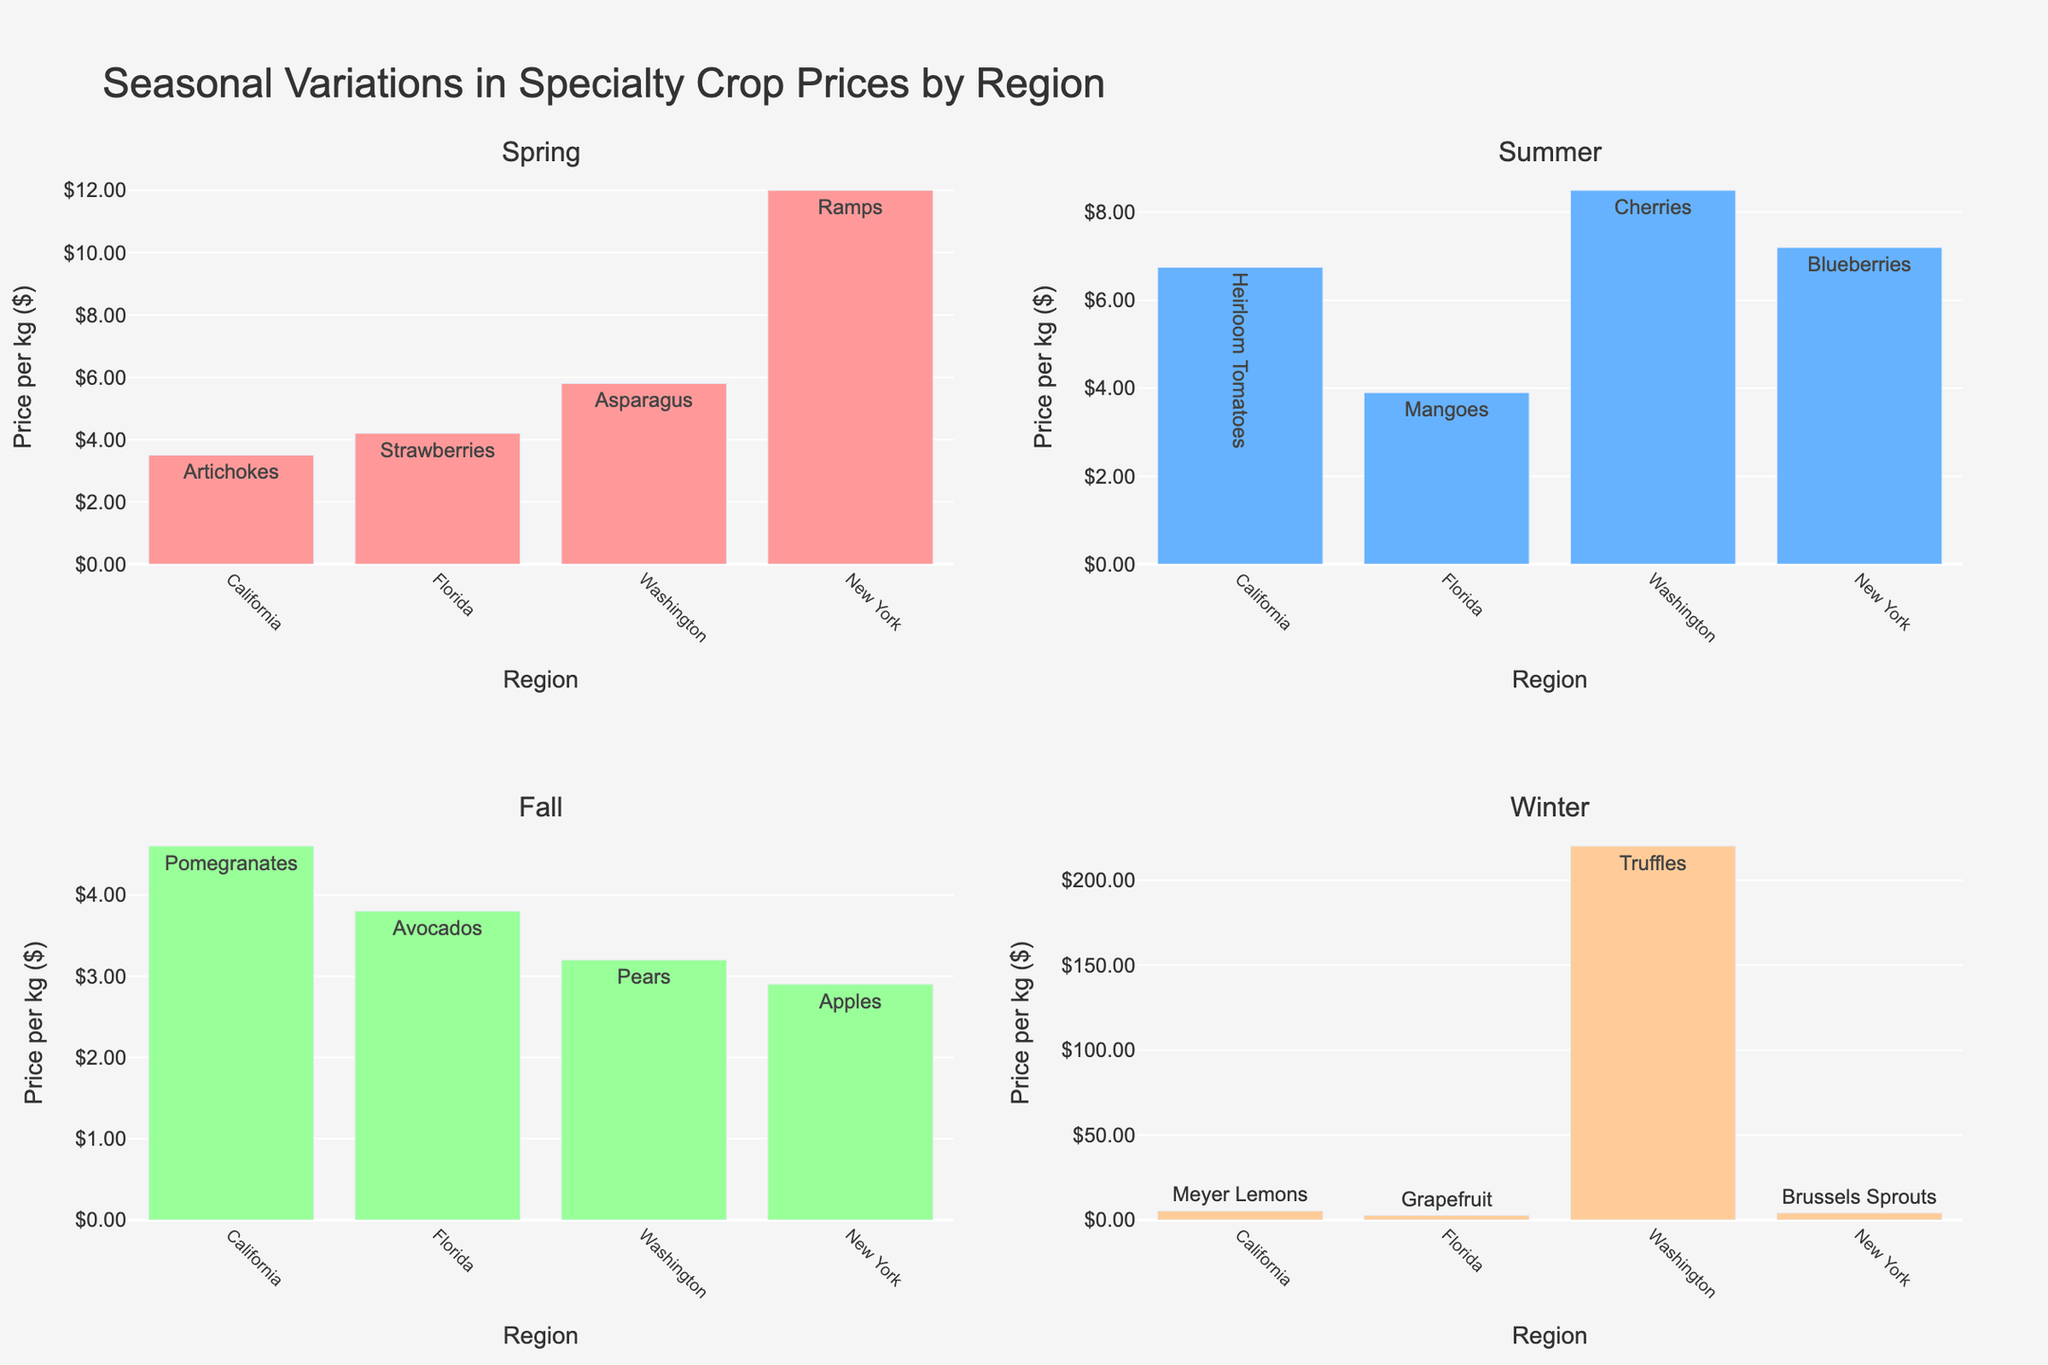How many regions are represented in the figure? There are four regions shown in each subplot: California, Florida, Washington, and New York. By counting them in any one of the subplots, we can determine the number of regions.
Answer: 4 Which season has the highest price for a single crop? The Winter subplot shows Truffles in Washington with a price of $220.00 per kg, which is the highest among all crops shown.
Answer: Winter Which region in the Spring season has the highest-priced crop, and what is it? In the Spring subplot, Ramps in New York are priced at $12.00 per kg which is the highest among the regions for this season.
Answer: New York, Ramps What is the average price of crops in the Summer season? Sum all the prices in the Summer subplot: $6.75 (California) + $3.90 (Florida) + $8.50 (Washington) + $7.20 (New York) = $26.35. Divide the total by 4 (number of regions): $26.35 / 4 = $6.5875.
Answer: $6.59 Compare the price of Apples in New York during the Fall season with the price of Pomegranates in California during the same season. Which is higher? In the Fall subplot, Apples in New York are priced at $2.90 per kg, while Pomegranates in California are priced at $4.60 per kg. Hence, Pomegranates are higher in price.
Answer: Pomegranates Which season has the lowest overall price for its crops, considering all regions? Adding up the prices for each season:
- Spring: $3.50 + $4.20 + $5.80 + $12.00 = $25.50
- Summer: $6.75 + $3.90 + $8.50 + $7.20 = $26.35
- Fall: $4.60 + $3.80 + $3.20 + $2.90 = $14.50
- Winter: $5.30 + $2.70 + $220.00 + $4.10 = $232.10
Among these totals, Fall has the lowest total price.
Answer: Fall What is the price difference between the most expensive and the least expensive crop in the Winter season? In the Winter subplot, the most expensive crop is Truffles ($220.00) and the least expensive is Grapefruit ($2.70). The difference is $220.00 - $2.70 = $217.30.
Answer: $217.30 Which crop is the most expensive in the Summer season? In the Summer subplot, Cherries in Washington are priced at $8.50 per kg, which is the highest price among the summer crops.
Answer: Cherries 